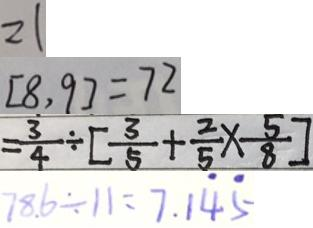Convert formula to latex. <formula><loc_0><loc_0><loc_500><loc_500>2 1 
 [ 8 , 9 ] = 7 2 
 = \frac { 3 } { 4 } \div [ \frac { 3 } { 5 } + \frac { 2 } { 5 } \times \frac { 5 } { 8 } ] 
 7 8 . 6 \div 1 1 = 7 . 1 \dot { 4 } \dot { 5 }</formula> 